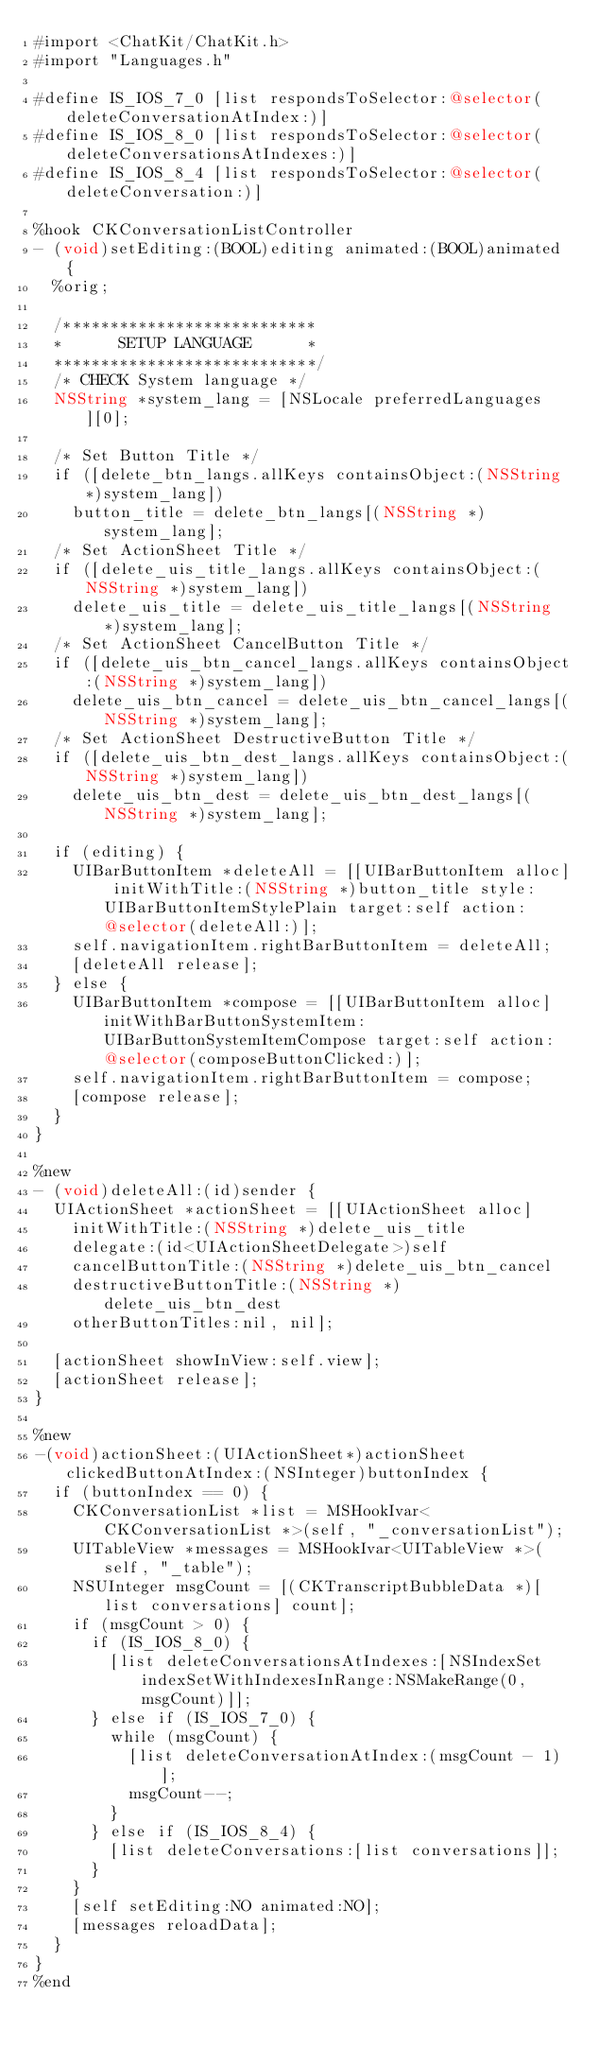Convert code to text. <code><loc_0><loc_0><loc_500><loc_500><_ObjectiveC_>#import <ChatKit/ChatKit.h>
#import "Languages.h"

#define IS_IOS_7_0 [list respondsToSelector:@selector(deleteConversationAtIndex:)]
#define IS_IOS_8_0 [list respondsToSelector:@selector(deleteConversationsAtIndexes:)]
#define IS_IOS_8_4 [list respondsToSelector:@selector(deleteConversation:)]

%hook CKConversationListController
- (void)setEditing:(BOOL)editing animated:(BOOL)animated {
	%orig;
	
	/***************************
	*      SETUP LANGUAGE      *
	****************************/
	/* CHECK System language */
	NSString *system_lang = [NSLocale preferredLanguages][0];
	
	/* Set Button Title */ 
	if ([delete_btn_langs.allKeys containsObject:(NSString *)system_lang])
		button_title = delete_btn_langs[(NSString *)system_lang];
	/* Set ActionSheet Title */
	if ([delete_uis_title_langs.allKeys containsObject:(NSString *)system_lang])
		delete_uis_title = delete_uis_title_langs[(NSString *)system_lang];
	/* Set ActionSheet CancelButton Title */
	if ([delete_uis_btn_cancel_langs.allKeys containsObject:(NSString *)system_lang])
		delete_uis_btn_cancel = delete_uis_btn_cancel_langs[(NSString *)system_lang];
	/* Set ActionSheet DestructiveButton Title */
	if ([delete_uis_btn_dest_langs.allKeys containsObject:(NSString *)system_lang])
		delete_uis_btn_dest = delete_uis_btn_dest_langs[(NSString *)system_lang];
	
	if (editing) {
		UIBarButtonItem *deleteAll = [[UIBarButtonItem alloc] initWithTitle:(NSString *)button_title style:UIBarButtonItemStylePlain target:self action:@selector(deleteAll:)];
		self.navigationItem.rightBarButtonItem = deleteAll;
		[deleteAll release];
	} else {
		UIBarButtonItem *compose = [[UIBarButtonItem alloc] initWithBarButtonSystemItem:UIBarButtonSystemItemCompose target:self action:@selector(composeButtonClicked:)];
		self.navigationItem.rightBarButtonItem = compose;
		[compose release];
	}
}

%new
- (void)deleteAll:(id)sender {
	UIActionSheet *actionSheet = [[UIActionSheet alloc]
		initWithTitle:(NSString *)delete_uis_title
		delegate:(id<UIActionSheetDelegate>)self
		cancelButtonTitle:(NSString *)delete_uis_btn_cancel
		destructiveButtonTitle:(NSString *)delete_uis_btn_dest
		otherButtonTitles:nil, nil];
	
	[actionSheet showInView:self.view];
	[actionSheet release];
}

%new
-(void)actionSheet:(UIActionSheet*)actionSheet clickedButtonAtIndex:(NSInteger)buttonIndex {
	if (buttonIndex == 0) {
		CKConversationList *list = MSHookIvar<CKConversationList *>(self, "_conversationList");
		UITableView *messages = MSHookIvar<UITableView *>(self, "_table");
		NSUInteger msgCount = [(CKTranscriptBubbleData *)[list conversations] count];
		if (msgCount > 0) {
			if (IS_IOS_8_0) {
				[list deleteConversationsAtIndexes:[NSIndexSet indexSetWithIndexesInRange:NSMakeRange(0, msgCount)]];
			} else if (IS_IOS_7_0) {
				while (msgCount) {
					[list deleteConversationAtIndex:(msgCount - 1)];
					msgCount--;
				}
			} else if (IS_IOS_8_4) {
				[list deleteConversations:[list conversations]];
			}
		}
		[self setEditing:NO animated:NO];
		[messages reloadData];
	}
}
%end

</code> 